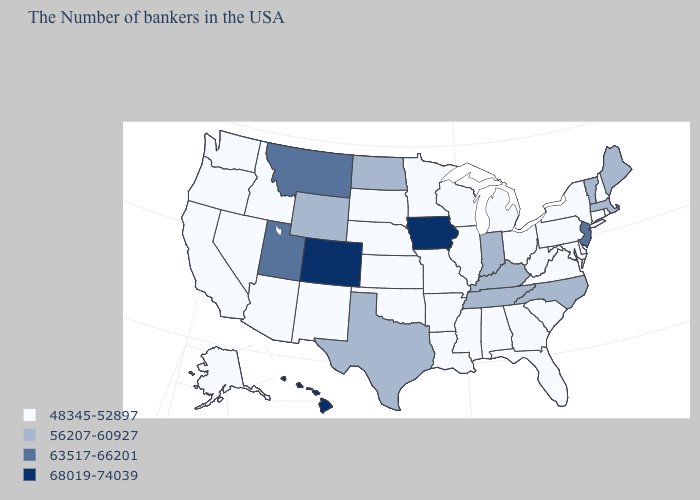What is the value of Indiana?
Give a very brief answer. 56207-60927. Name the states that have a value in the range 68019-74039?
Keep it brief. Iowa, Colorado, Hawaii. Among the states that border North Carolina , does Virginia have the lowest value?
Give a very brief answer. Yes. Does Rhode Island have the lowest value in the USA?
Quick response, please. Yes. Name the states that have a value in the range 68019-74039?
Concise answer only. Iowa, Colorado, Hawaii. Does Wyoming have the highest value in the USA?
Short answer required. No. Does Minnesota have the highest value in the MidWest?
Be succinct. No. What is the highest value in the South ?
Give a very brief answer. 56207-60927. Does the map have missing data?
Write a very short answer. No. Which states have the lowest value in the Northeast?
Give a very brief answer. Rhode Island, New Hampshire, Connecticut, New York, Pennsylvania. Does Texas have the highest value in the South?
Write a very short answer. Yes. Does the first symbol in the legend represent the smallest category?
Be succinct. Yes. Among the states that border New Hampshire , which have the lowest value?
Be succinct. Maine, Massachusetts, Vermont. What is the value of New Hampshire?
Concise answer only. 48345-52897. Name the states that have a value in the range 68019-74039?
Keep it brief. Iowa, Colorado, Hawaii. 